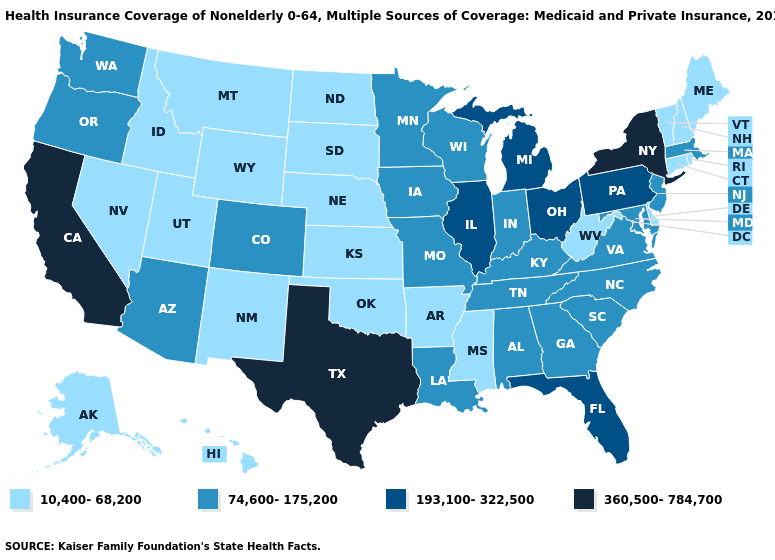Name the states that have a value in the range 193,100-322,500?
Write a very short answer. Florida, Illinois, Michigan, Ohio, Pennsylvania. Name the states that have a value in the range 360,500-784,700?
Quick response, please. California, New York, Texas. What is the lowest value in the USA?
Be succinct. 10,400-68,200. Does Ohio have the same value as New Hampshire?
Write a very short answer. No. How many symbols are there in the legend?
Write a very short answer. 4. What is the lowest value in the USA?
Quick response, please. 10,400-68,200. What is the highest value in the MidWest ?
Write a very short answer. 193,100-322,500. Does Wyoming have the lowest value in the USA?
Write a very short answer. Yes. Name the states that have a value in the range 193,100-322,500?
Short answer required. Florida, Illinois, Michigan, Ohio, Pennsylvania. What is the highest value in states that border Louisiana?
Keep it brief. 360,500-784,700. What is the value of Illinois?
Short answer required. 193,100-322,500. What is the value of Minnesota?
Quick response, please. 74,600-175,200. What is the value of Maryland?
Answer briefly. 74,600-175,200. Which states have the lowest value in the West?
Concise answer only. Alaska, Hawaii, Idaho, Montana, Nevada, New Mexico, Utah, Wyoming. Which states have the lowest value in the USA?
Quick response, please. Alaska, Arkansas, Connecticut, Delaware, Hawaii, Idaho, Kansas, Maine, Mississippi, Montana, Nebraska, Nevada, New Hampshire, New Mexico, North Dakota, Oklahoma, Rhode Island, South Dakota, Utah, Vermont, West Virginia, Wyoming. 